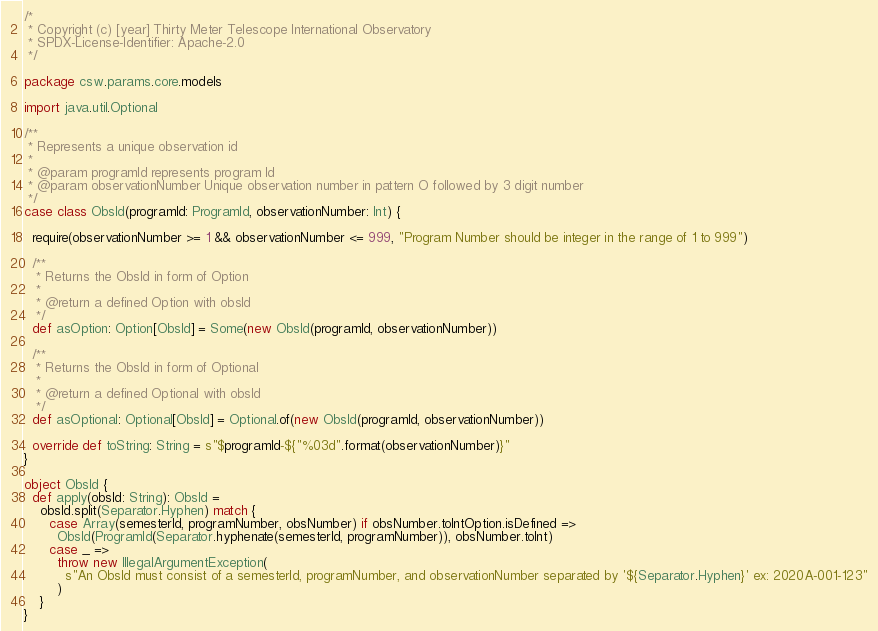Convert code to text. <code><loc_0><loc_0><loc_500><loc_500><_Scala_>/*
 * Copyright (c) [year] Thirty Meter Telescope International Observatory
 * SPDX-License-Identifier: Apache-2.0
 */

package csw.params.core.models

import java.util.Optional

/**
 * Represents a unique observation id
 *
 * @param programId represents program Id
 * @param observationNumber Unique observation number in pattern O followed by 3 digit number
 */
case class ObsId(programId: ProgramId, observationNumber: Int) {

  require(observationNumber >= 1 && observationNumber <= 999, "Program Number should be integer in the range of 1 to 999")

  /**
   * Returns the ObsId in form of Option
   *
   * @return a defined Option with obsId
   */
  def asOption: Option[ObsId] = Some(new ObsId(programId, observationNumber))

  /**
   * Returns the ObsId in form of Optional
   *
   * @return a defined Optional with obsId
   */
  def asOptional: Optional[ObsId] = Optional.of(new ObsId(programId, observationNumber))

  override def toString: String = s"$programId-${"%03d".format(observationNumber)}"
}

object ObsId {
  def apply(obsId: String): ObsId =
    obsId.split(Separator.Hyphen) match {
      case Array(semesterId, programNumber, obsNumber) if obsNumber.toIntOption.isDefined =>
        ObsId(ProgramId(Separator.hyphenate(semesterId, programNumber)), obsNumber.toInt)
      case _ =>
        throw new IllegalArgumentException(
          s"An ObsId must consist of a semesterId, programNumber, and observationNumber separated by '${Separator.Hyphen}' ex: 2020A-001-123"
        )
    }
}
</code> 